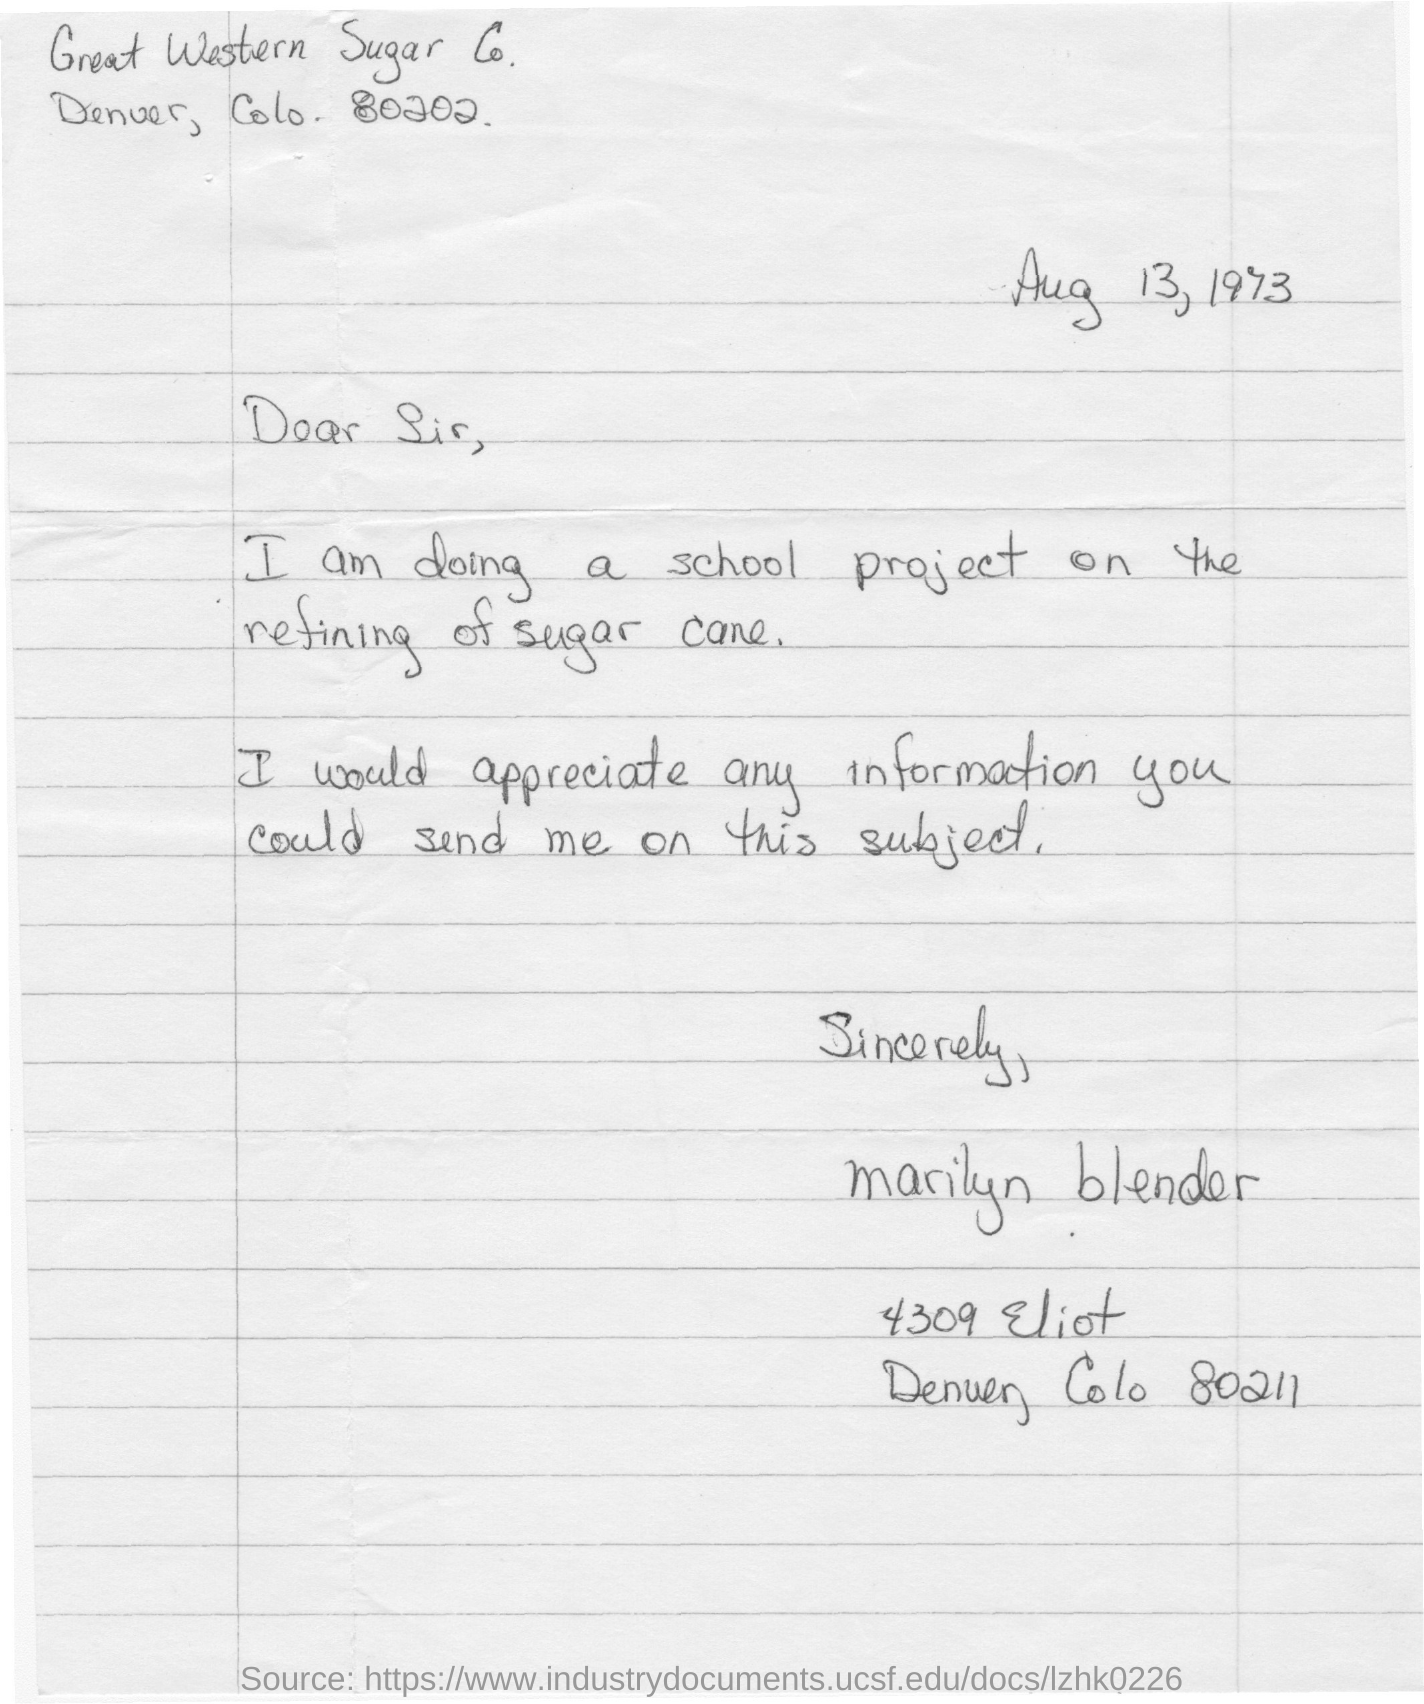What is the date mentioned in the letter?
Ensure brevity in your answer.  Aug 13, 1973. What is the date on the letter?
Make the answer very short. Aug 13, 1973. What project is the student doing?
Offer a terse response. School project on the refining of sugar cane. Who written this letter to the sugar company?
Your response must be concise. Marilyn blender. 